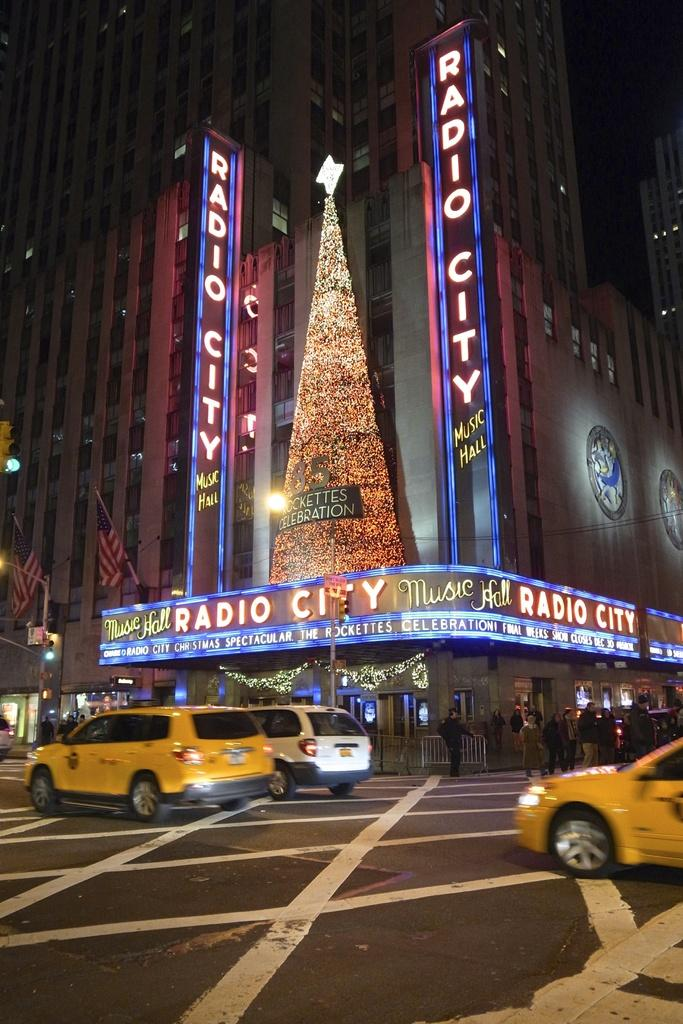<image>
Relay a brief, clear account of the picture shown. Radio City Music Hall has a huge Christmas tree on it's balcony, and advertises the Rockettes on the sign. 